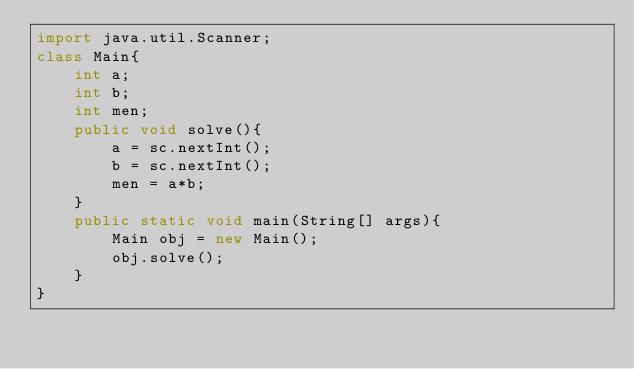Convert code to text. <code><loc_0><loc_0><loc_500><loc_500><_Java_>import java.util.Scanner;
class Main{
    int a;
    int b;
    int men;
    public void solve(){
        a = sc.nextInt();
        b = sc.nextInt();
        men = a*b;
    }
    public static void main(String[] args){
        Main obj = new Main();
        obj.solve();
    }
}</code> 